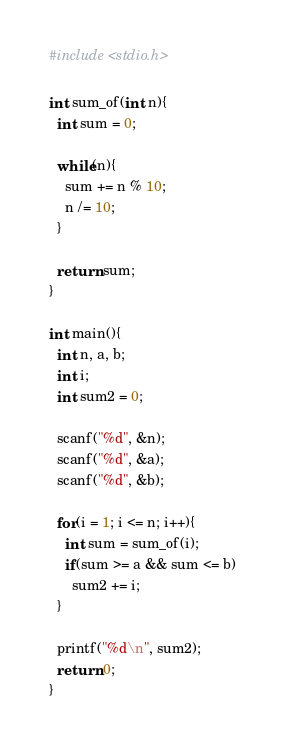<code> <loc_0><loc_0><loc_500><loc_500><_C_>#include <stdio.h>

int sum_of(int n){
  int sum = 0;
  
  while(n){
    sum += n % 10;
    n /= 10;
  }
  
  return sum;
}

int main(){
  int n, a, b;
  int i;
  int sum2 = 0;
  
  scanf("%d", &n);
  scanf("%d", &a);
  scanf("%d", &b);
  
  for(i = 1; i <= n; i++){
    int sum = sum_of(i);
    if(sum >= a && sum <= b)
      sum2 += i;
  }
  
  printf("%d\n", sum2);
  return 0;
}
</code> 